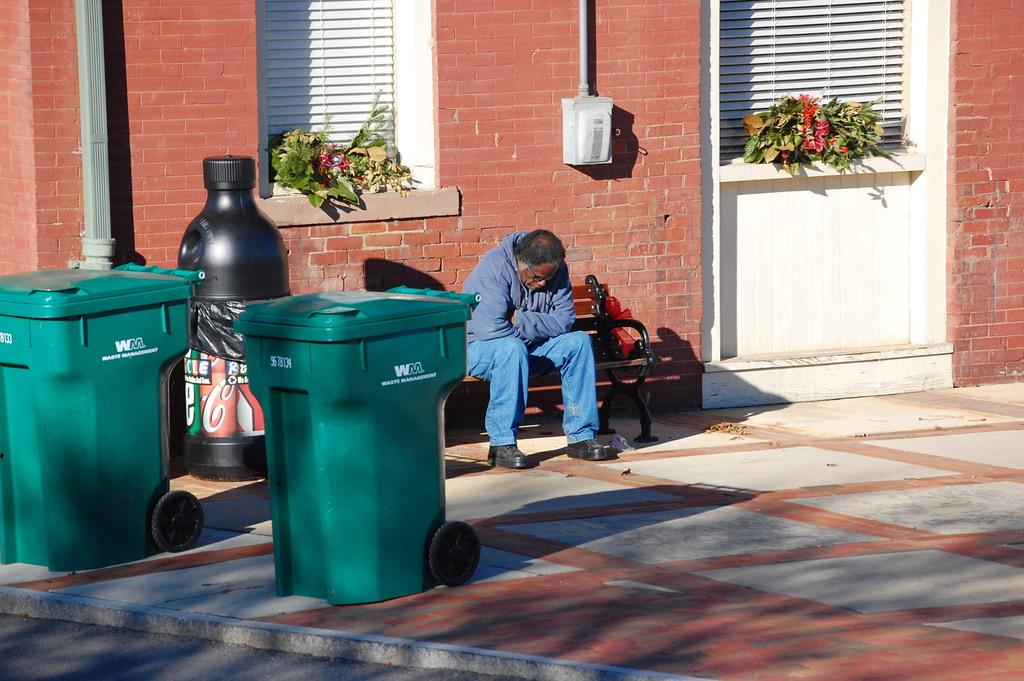What letters are found on the trash can?
Your response must be concise. Wm. 